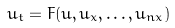Convert formula to latex. <formula><loc_0><loc_0><loc_500><loc_500>u _ { t } = F ( u , u _ { x } , \dots , u _ { n x } )</formula> 